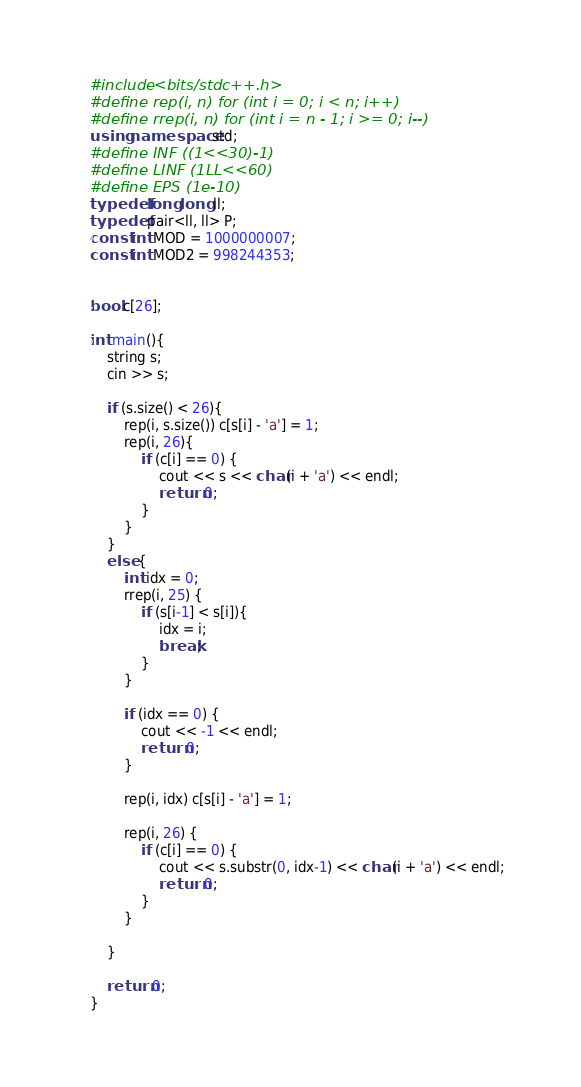<code> <loc_0><loc_0><loc_500><loc_500><_C++_>#include <bits/stdc++.h>
#define rep(i, n) for (int i = 0; i < n; i++)
#define rrep(i, n) for (int i = n - 1; i >= 0; i--)
using namespace std;
#define INF ((1<<30)-1)
#define LINF (1LL<<60)
#define EPS (1e-10)
typedef long long ll;
typedef pair<ll, ll> P;
const int MOD = 1000000007;
const int MOD2 = 998244353;


bool c[26];

int main(){
    string s;
    cin >> s;

    if (s.size() < 26){
        rep(i, s.size()) c[s[i] - 'a'] = 1;
        rep(i, 26){
            if (c[i] == 0) {
                cout << s << char(i + 'a') << endl;
                return 0;
            }
        }
    }
    else {
        int idx = 0;
        rrep(i, 25) {
            if (s[i-1] < s[i]){
                idx = i;
                break;
            }
        }

        if (idx == 0) {
            cout << -1 << endl;
            return 0;
        }

        rep(i, idx) c[s[i] - 'a'] = 1;

        rep(i, 26) {
            if (c[i] == 0) {
                cout << s.substr(0, idx-1) << char(i + 'a') << endl;
                return 0;
            }
        }

    }

    return 0;
}
</code> 